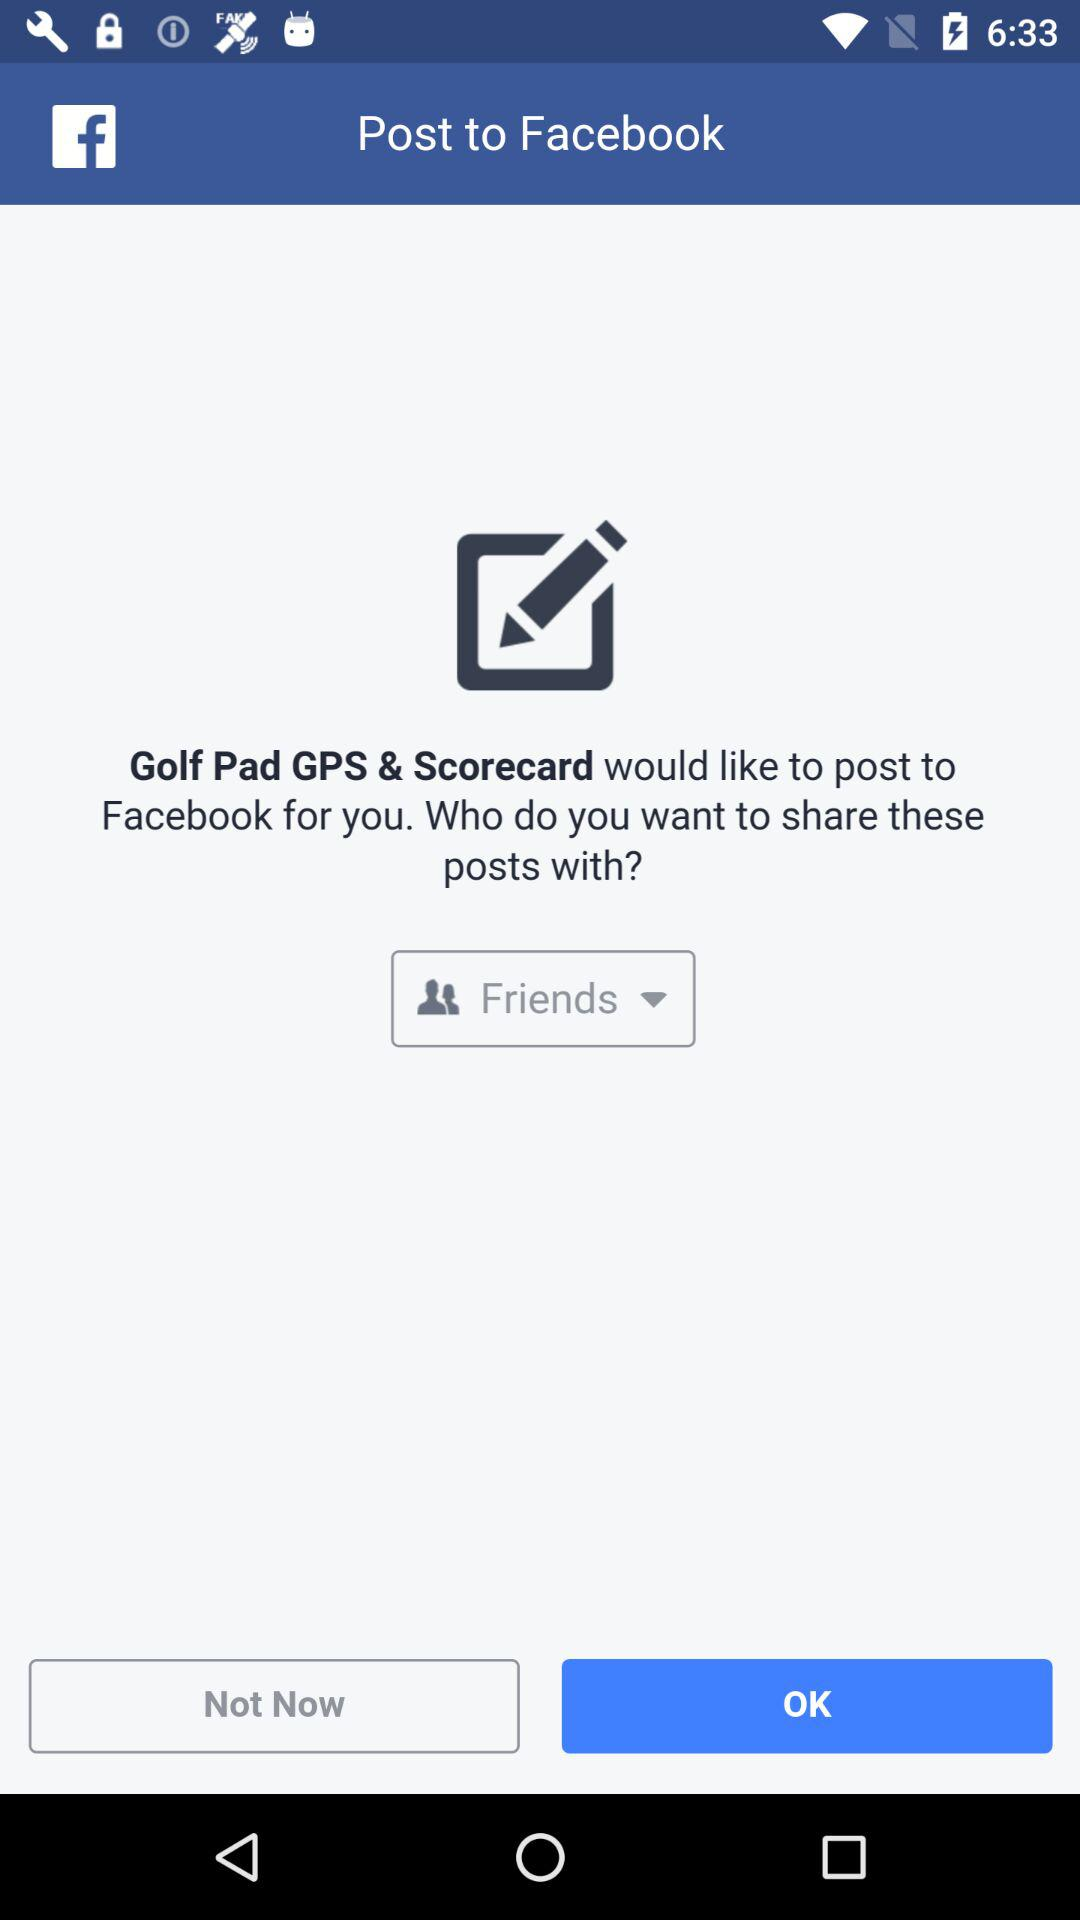Which option is selected? The selected option is "Friends". 